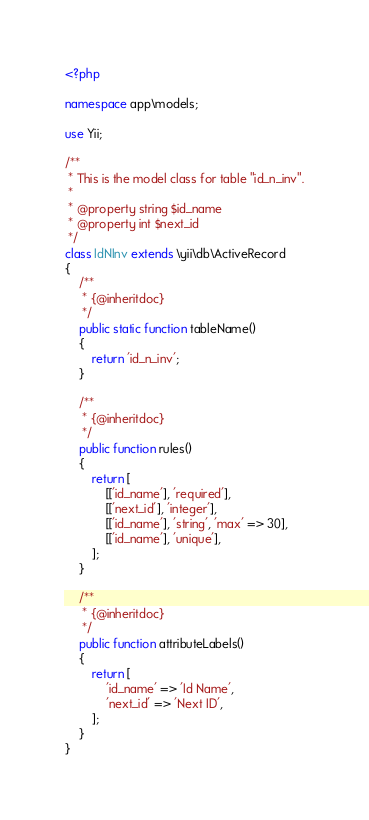Convert code to text. <code><loc_0><loc_0><loc_500><loc_500><_PHP_><?php

namespace app\models;

use Yii;

/**
 * This is the model class for table "id_n_inv".
 *
 * @property string $id_name
 * @property int $next_id
 */
class IdNInv extends \yii\db\ActiveRecord
{
    /**
     * {@inheritdoc}
     */
    public static function tableName()
    {
        return 'id_n_inv';
    }

    /**
     * {@inheritdoc}
     */
    public function rules()
    {
        return [
            [['id_name'], 'required'],
            [['next_id'], 'integer'],
            [['id_name'], 'string', 'max' => 30],
            [['id_name'], 'unique'],
        ];
    }

    /**
     * {@inheritdoc}
     */
    public function attributeLabels()
    {
        return [
            'id_name' => 'Id Name',
            'next_id' => 'Next ID',
        ];
    }
}
</code> 